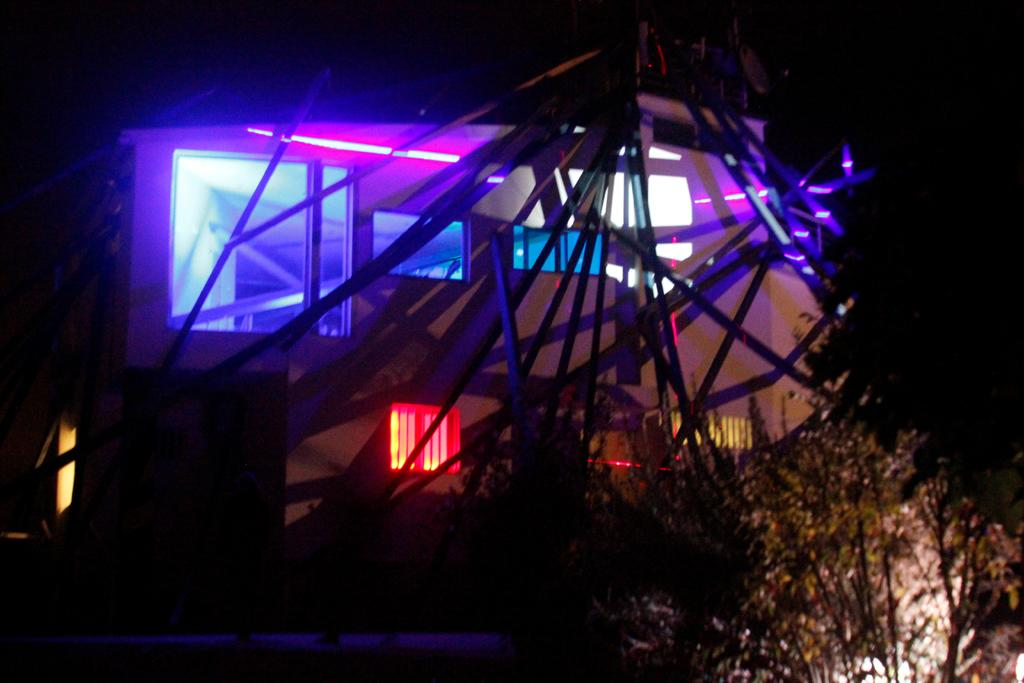What type of structure is in the image? There is a building in the image. What can be seen in the background of the image? There are trees visible in the image. What else is present in the image besides the building and trees? There are lights present in the image. How many bananas are hanging from the building in the image? There are no bananas present in the image. What type of love is being expressed by the trees in the image? The trees in the image are not expressing any type of love; they are simply trees. 